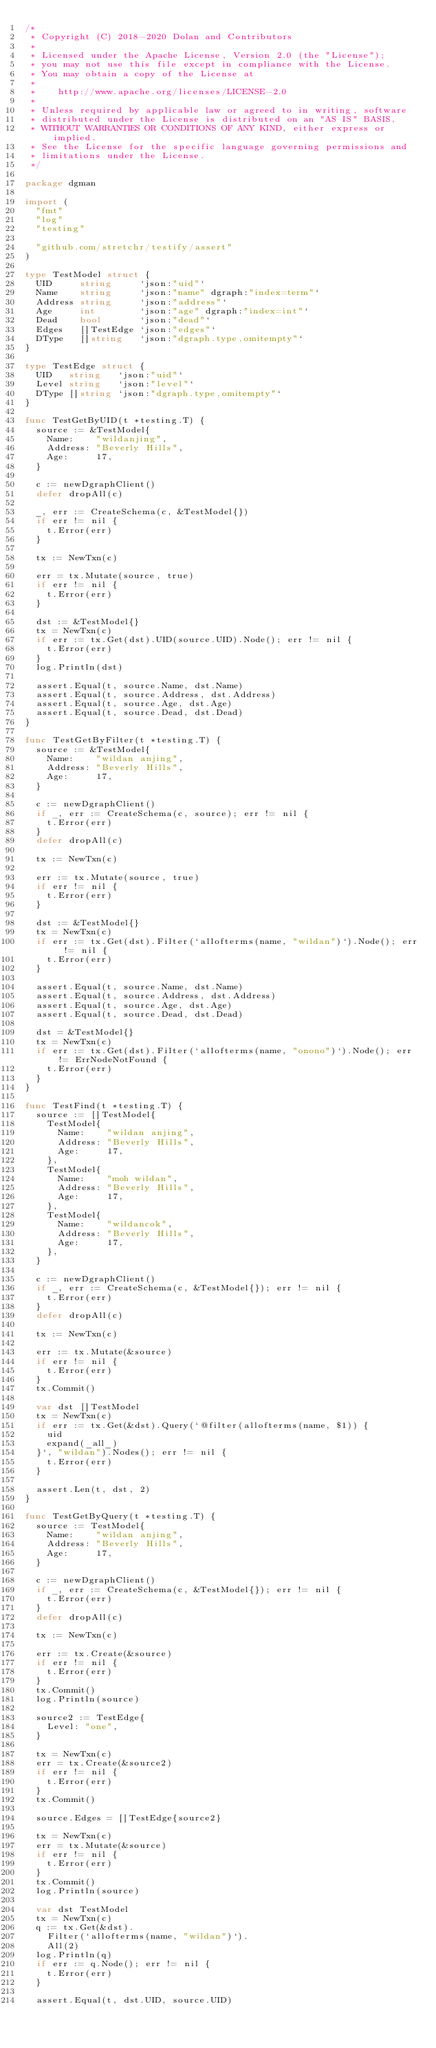<code> <loc_0><loc_0><loc_500><loc_500><_Go_>/*
 * Copyright (C) 2018-2020 Dolan and Contributors
 *
 * Licensed under the Apache License, Version 2.0 (the "License");
 * you may not use this file except in compliance with the License.
 * You may obtain a copy of the License at
 *
 *    http://www.apache.org/licenses/LICENSE-2.0
 *
 * Unless required by applicable law or agreed to in writing, software
 * distributed under the License is distributed on an "AS IS" BASIS,
 * WITHOUT WARRANTIES OR CONDITIONS OF ANY KIND, either express or implied.
 * See the License for the specific language governing permissions and
 * limitations under the License.
 */

package dgman

import (
	"fmt"
	"log"
	"testing"

	"github.com/stretchr/testify/assert"
)

type TestModel struct {
	UID     string     `json:"uid"`
	Name    string     `json:"name" dgraph:"index=term"`
	Address string     `json:"address"`
	Age     int        `json:"age" dgraph:"index=int"`
	Dead    bool       `json:"dead"`
	Edges   []TestEdge `json:"edges"`
	DType   []string   `json:"dgraph.type,omitempty"`
}

type TestEdge struct {
	UID   string   `json:"uid"`
	Level string   `json:"level"`
	DType []string `json:"dgraph.type,omitempty"`
}

func TestGetByUID(t *testing.T) {
	source := &TestModel{
		Name:    "wildanjing",
		Address: "Beverly Hills",
		Age:     17,
	}

	c := newDgraphClient()
	defer dropAll(c)

	_, err := CreateSchema(c, &TestModel{})
	if err != nil {
		t.Error(err)
	}

	tx := NewTxn(c)

	err = tx.Mutate(source, true)
	if err != nil {
		t.Error(err)
	}

	dst := &TestModel{}
	tx = NewTxn(c)
	if err := tx.Get(dst).UID(source.UID).Node(); err != nil {
		t.Error(err)
	}
	log.Println(dst)

	assert.Equal(t, source.Name, dst.Name)
	assert.Equal(t, source.Address, dst.Address)
	assert.Equal(t, source.Age, dst.Age)
	assert.Equal(t, source.Dead, dst.Dead)
}

func TestGetByFilter(t *testing.T) {
	source := &TestModel{
		Name:    "wildan anjing",
		Address: "Beverly Hills",
		Age:     17,
	}

	c := newDgraphClient()
	if _, err := CreateSchema(c, source); err != nil {
		t.Error(err)
	}
	defer dropAll(c)

	tx := NewTxn(c)

	err := tx.Mutate(source, true)
	if err != nil {
		t.Error(err)
	}

	dst := &TestModel{}
	tx = NewTxn(c)
	if err := tx.Get(dst).Filter(`allofterms(name, "wildan")`).Node(); err != nil {
		t.Error(err)
	}

	assert.Equal(t, source.Name, dst.Name)
	assert.Equal(t, source.Address, dst.Address)
	assert.Equal(t, source.Age, dst.Age)
	assert.Equal(t, source.Dead, dst.Dead)

	dst = &TestModel{}
	tx = NewTxn(c)
	if err := tx.Get(dst).Filter(`allofterms(name, "onono")`).Node(); err != ErrNodeNotFound {
		t.Error(err)
	}
}

func TestFind(t *testing.T) {
	source := []TestModel{
		TestModel{
			Name:    "wildan anjing",
			Address: "Beverly Hills",
			Age:     17,
		},
		TestModel{
			Name:    "moh wildan",
			Address: "Beverly Hills",
			Age:     17,
		},
		TestModel{
			Name:    "wildancok",
			Address: "Beverly Hills",
			Age:     17,
		},
	}

	c := newDgraphClient()
	if _, err := CreateSchema(c, &TestModel{}); err != nil {
		t.Error(err)
	}
	defer dropAll(c)

	tx := NewTxn(c)

	err := tx.Mutate(&source)
	if err != nil {
		t.Error(err)
	}
	tx.Commit()

	var dst []TestModel
	tx = NewTxn(c)
	if err := tx.Get(&dst).Query(`@filter(allofterms(name, $1)) { 
		uid
		expand(_all_)
	}`, "wildan").Nodes(); err != nil {
		t.Error(err)
	}

	assert.Len(t, dst, 2)
}

func TestGetByQuery(t *testing.T) {
	source := TestModel{
		Name:    "wildan anjing",
		Address: "Beverly Hills",
		Age:     17,
	}

	c := newDgraphClient()
	if _, err := CreateSchema(c, &TestModel{}); err != nil {
		t.Error(err)
	}
	defer dropAll(c)

	tx := NewTxn(c)

	err := tx.Create(&source)
	if err != nil {
		t.Error(err)
	}
	tx.Commit()
	log.Println(source)

	source2 := TestEdge{
		Level: "one",
	}

	tx = NewTxn(c)
	err = tx.Create(&source2)
	if err != nil {
		t.Error(err)
	}
	tx.Commit()

	source.Edges = []TestEdge{source2}

	tx = NewTxn(c)
	err = tx.Mutate(&source)
	if err != nil {
		t.Error(err)
	}
	tx.Commit()
	log.Println(source)

	var dst TestModel
	tx = NewTxn(c)
	q := tx.Get(&dst).
		Filter(`allofterms(name, "wildan")`).
		All(2)
	log.Println(q)
	if err := q.Node(); err != nil {
		t.Error(err)
	}

	assert.Equal(t, dst.UID, source.UID)</code> 